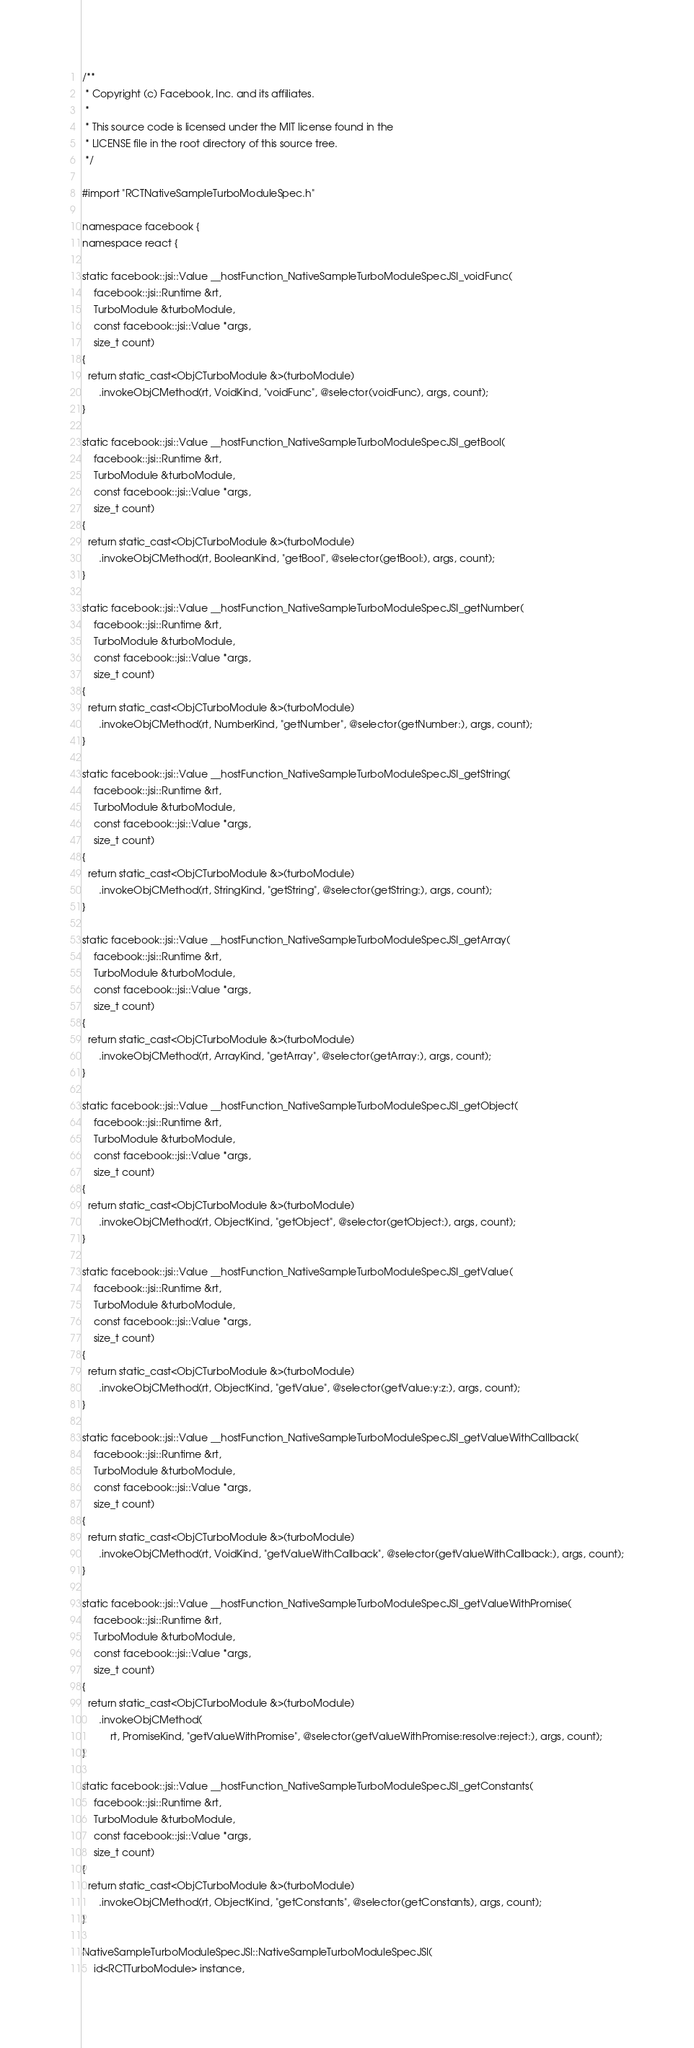Convert code to text. <code><loc_0><loc_0><loc_500><loc_500><_ObjectiveC_>/**
 * Copyright (c) Facebook, Inc. and its affiliates.
 *
 * This source code is licensed under the MIT license found in the
 * LICENSE file in the root directory of this source tree.
 */

#import "RCTNativeSampleTurboModuleSpec.h"

namespace facebook {
namespace react {

static facebook::jsi::Value __hostFunction_NativeSampleTurboModuleSpecJSI_voidFunc(
    facebook::jsi::Runtime &rt,
    TurboModule &turboModule,
    const facebook::jsi::Value *args,
    size_t count)
{
  return static_cast<ObjCTurboModule &>(turboModule)
      .invokeObjCMethod(rt, VoidKind, "voidFunc", @selector(voidFunc), args, count);
}

static facebook::jsi::Value __hostFunction_NativeSampleTurboModuleSpecJSI_getBool(
    facebook::jsi::Runtime &rt,
    TurboModule &turboModule,
    const facebook::jsi::Value *args,
    size_t count)
{
  return static_cast<ObjCTurboModule &>(turboModule)
      .invokeObjCMethod(rt, BooleanKind, "getBool", @selector(getBool:), args, count);
}

static facebook::jsi::Value __hostFunction_NativeSampleTurboModuleSpecJSI_getNumber(
    facebook::jsi::Runtime &rt,
    TurboModule &turboModule,
    const facebook::jsi::Value *args,
    size_t count)
{
  return static_cast<ObjCTurboModule &>(turboModule)
      .invokeObjCMethod(rt, NumberKind, "getNumber", @selector(getNumber:), args, count);
}

static facebook::jsi::Value __hostFunction_NativeSampleTurboModuleSpecJSI_getString(
    facebook::jsi::Runtime &rt,
    TurboModule &turboModule,
    const facebook::jsi::Value *args,
    size_t count)
{
  return static_cast<ObjCTurboModule &>(turboModule)
      .invokeObjCMethod(rt, StringKind, "getString", @selector(getString:), args, count);
}

static facebook::jsi::Value __hostFunction_NativeSampleTurboModuleSpecJSI_getArray(
    facebook::jsi::Runtime &rt,
    TurboModule &turboModule,
    const facebook::jsi::Value *args,
    size_t count)
{
  return static_cast<ObjCTurboModule &>(turboModule)
      .invokeObjCMethod(rt, ArrayKind, "getArray", @selector(getArray:), args, count);
}

static facebook::jsi::Value __hostFunction_NativeSampleTurboModuleSpecJSI_getObject(
    facebook::jsi::Runtime &rt,
    TurboModule &turboModule,
    const facebook::jsi::Value *args,
    size_t count)
{
  return static_cast<ObjCTurboModule &>(turboModule)
      .invokeObjCMethod(rt, ObjectKind, "getObject", @selector(getObject:), args, count);
}

static facebook::jsi::Value __hostFunction_NativeSampleTurboModuleSpecJSI_getValue(
    facebook::jsi::Runtime &rt,
    TurboModule &turboModule,
    const facebook::jsi::Value *args,
    size_t count)
{
  return static_cast<ObjCTurboModule &>(turboModule)
      .invokeObjCMethod(rt, ObjectKind, "getValue", @selector(getValue:y:z:), args, count);
}

static facebook::jsi::Value __hostFunction_NativeSampleTurboModuleSpecJSI_getValueWithCallback(
    facebook::jsi::Runtime &rt,
    TurboModule &turboModule,
    const facebook::jsi::Value *args,
    size_t count)
{
  return static_cast<ObjCTurboModule &>(turboModule)
      .invokeObjCMethod(rt, VoidKind, "getValueWithCallback", @selector(getValueWithCallback:), args, count);
}

static facebook::jsi::Value __hostFunction_NativeSampleTurboModuleSpecJSI_getValueWithPromise(
    facebook::jsi::Runtime &rt,
    TurboModule &turboModule,
    const facebook::jsi::Value *args,
    size_t count)
{
  return static_cast<ObjCTurboModule &>(turboModule)
      .invokeObjCMethod(
          rt, PromiseKind, "getValueWithPromise", @selector(getValueWithPromise:resolve:reject:), args, count);
}

static facebook::jsi::Value __hostFunction_NativeSampleTurboModuleSpecJSI_getConstants(
    facebook::jsi::Runtime &rt,
    TurboModule &turboModule,
    const facebook::jsi::Value *args,
    size_t count)
{
  return static_cast<ObjCTurboModule &>(turboModule)
      .invokeObjCMethod(rt, ObjectKind, "getConstants", @selector(getConstants), args, count);
}

NativeSampleTurboModuleSpecJSI::NativeSampleTurboModuleSpecJSI(
    id<RCTTurboModule> instance,</code> 